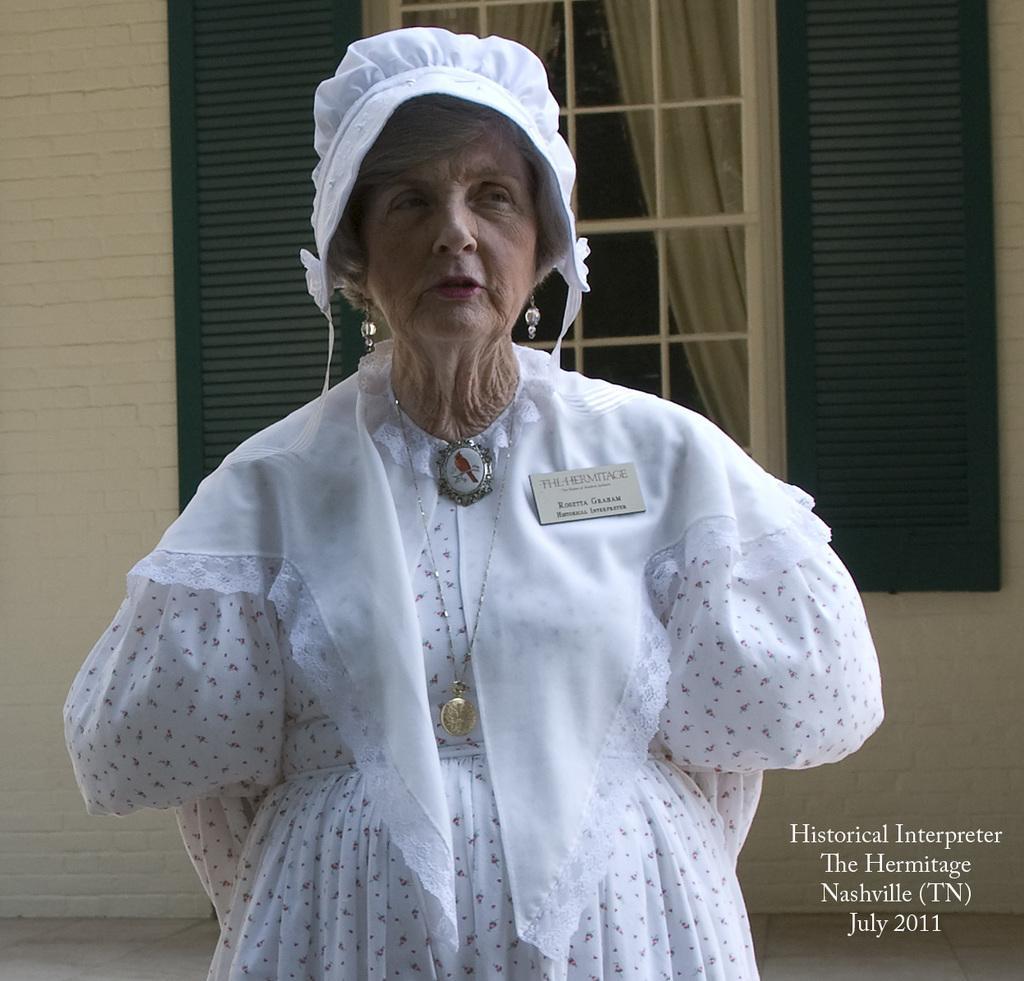Could you give a brief overview of what you see in this image? This is an old woman standing. She wore a white dress. This looks like a badge, which is attached to the dress. In the background, I can see a window with the doors. I think these are the curtains hanging, which are behind the window. This is the watermark on the image. 